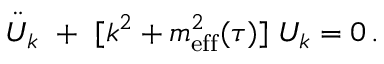Convert formula to latex. <formula><loc_0><loc_0><loc_500><loc_500>\ddot { U } _ { k } + [ k ^ { 2 } + m _ { e f f } ^ { 2 } ( \tau ) ] \, U _ { k } = 0 \, .</formula> 